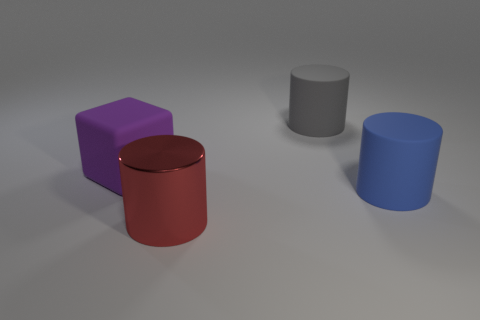Is the shape of the blue matte object the same as the large thing in front of the large blue rubber cylinder? The blue matte object appears to be a cylinder, similar in shape to the large red object in front of it, though the materials and colors are different. Both objects have a cylindrical shape with circular tops, but the blue cylinder has a consistent diameter, while the red cylinder seems to taper slightly toward the top. 